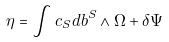<formula> <loc_0><loc_0><loc_500><loc_500>\eta = \int c _ { S } d b ^ { S } \wedge \Omega + \delta \Psi</formula> 